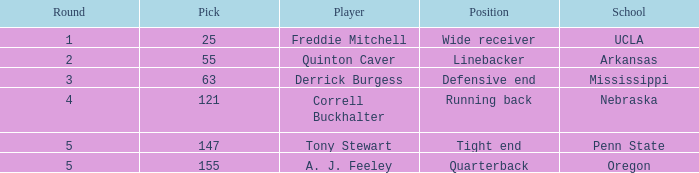Who was the player who was pick number 147? Tony Stewart. 